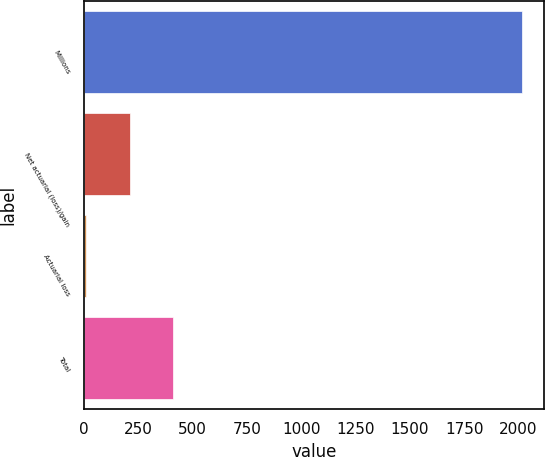<chart> <loc_0><loc_0><loc_500><loc_500><bar_chart><fcel>Millions<fcel>Net actuarial (loss)/gain<fcel>Actuarial loss<fcel>Total<nl><fcel>2018<fcel>210.8<fcel>10<fcel>411.6<nl></chart> 